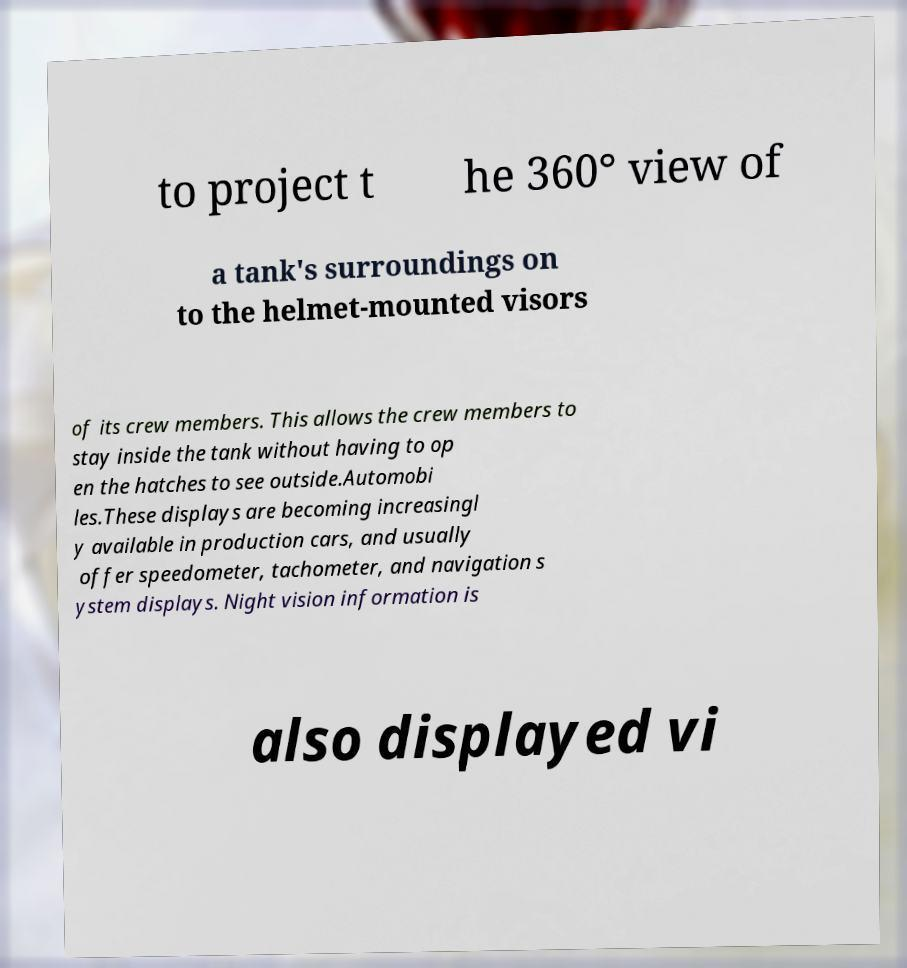Can you accurately transcribe the text from the provided image for me? to project t he 360° view of a tank's surroundings on to the helmet-mounted visors of its crew members. This allows the crew members to stay inside the tank without having to op en the hatches to see outside.Automobi les.These displays are becoming increasingl y available in production cars, and usually offer speedometer, tachometer, and navigation s ystem displays. Night vision information is also displayed vi 